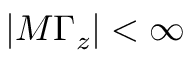<formula> <loc_0><loc_0><loc_500><loc_500>| M \Gamma _ { z } | < \infty</formula> 